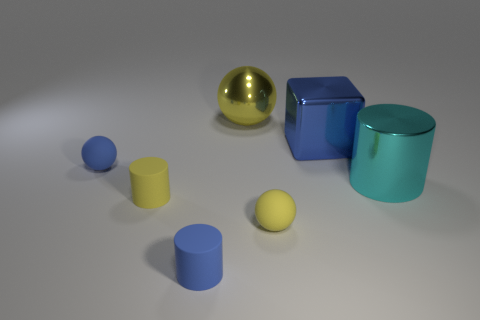How many balls have the same size as the yellow rubber cylinder?
Offer a very short reply. 2. Is there a small blue ball?
Give a very brief answer. Yes. Is there anything else that is the same color as the large metallic ball?
Make the answer very short. Yes. The cyan thing that is the same material as the large sphere is what shape?
Your answer should be compact. Cylinder. There is a cylinder that is right of the small rubber sphere that is in front of the cylinder to the right of the large cube; what color is it?
Offer a terse response. Cyan. Is the number of cyan metal objects on the right side of the cyan shiny cylinder the same as the number of small cyan metallic spheres?
Your response must be concise. Yes. Is there any other thing that has the same material as the cyan cylinder?
Make the answer very short. Yes. There is a shiny ball; is it the same color as the small rubber sphere to the left of the tiny yellow cylinder?
Offer a terse response. No. There is a tiny blue thing that is behind the big shiny thing that is in front of the tiny blue rubber sphere; is there a tiny thing that is right of it?
Make the answer very short. Yes. Are there fewer blue spheres in front of the yellow metal ball than big yellow matte spheres?
Keep it short and to the point. No. 